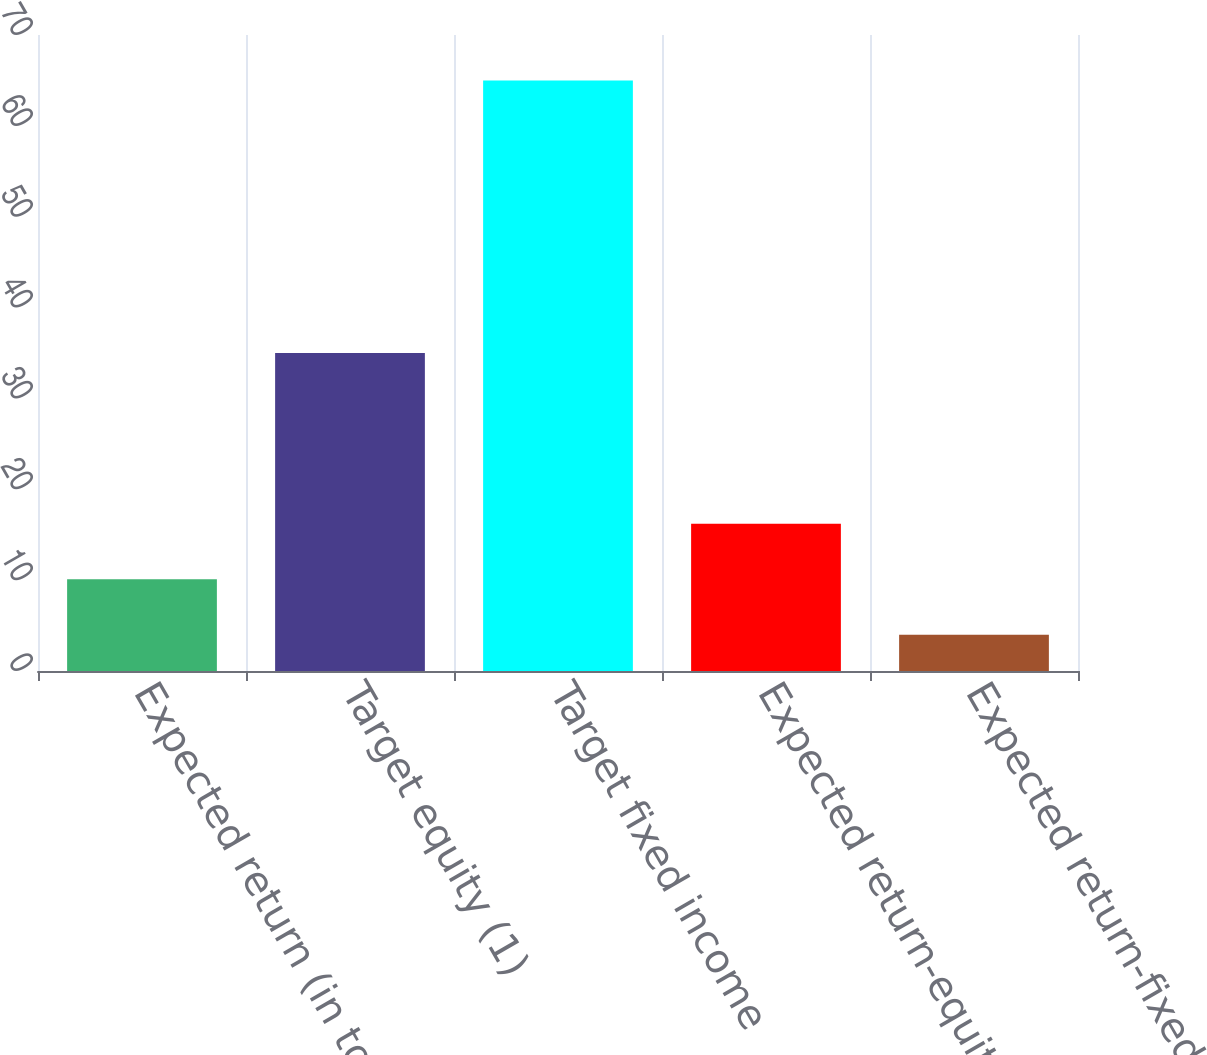Convert chart to OTSL. <chart><loc_0><loc_0><loc_500><loc_500><bar_chart><fcel>Expected return (in total)<fcel>Target equity (1)<fcel>Target fixed income<fcel>Expected return-equity (1)<fcel>Expected return-fixed income<nl><fcel>10.1<fcel>35<fcel>65<fcel>16.2<fcel>4<nl></chart> 